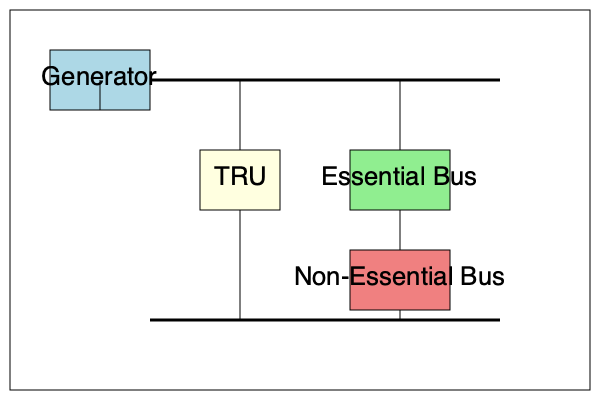In the given block diagram of an aircraft's power distribution system, what is the primary function of the TRU (Transformer Rectifier Unit) in relation to the Essential Bus and Non-Essential Bus? To understand the function of the TRU in this power distribution system, let's analyze the diagram step-by-step:

1. Generator: The primary source of electrical power in the aircraft.

2. Bus Bars: Two horizontal lines representing the main power distribution paths.

3. TRU (Transformer Rectifier Unit):
   - Connected to both the upper and lower bus bars
   - Placed before the Essential Bus and Non-Essential Bus

4. Essential Bus: Directly connected to the upper bus bar and the TRU

5. Non-Essential Bus: Connected to the lower bus bar and indirectly to the TRU

The TRU's position and connections in the diagram indicate its primary functions:

a) Voltage Transformation: The TRU likely steps down the voltage from the generator to a level suitable for the buses and connected equipment.

b) AC to DC Conversion: Given its name (Rectifier), the TRU converts the AC power from the generator to DC power for systems that require it.

c) Power Conditioning: The TRU helps maintain stable power output, protecting sensitive equipment on the Essential and Non-Essential buses.

d) Power Distribution: By connecting to both buses, the TRU plays a role in distributing power between the Essential and Non-Essential systems.

The key point is that the TRU is positioned to process the power before it reaches both the Essential and Non-Essential buses, indicating its critical role in preparing and distributing the electrical power for various aircraft systems.
Answer: Convert and condition power for distribution to Essential and Non-Essential buses 